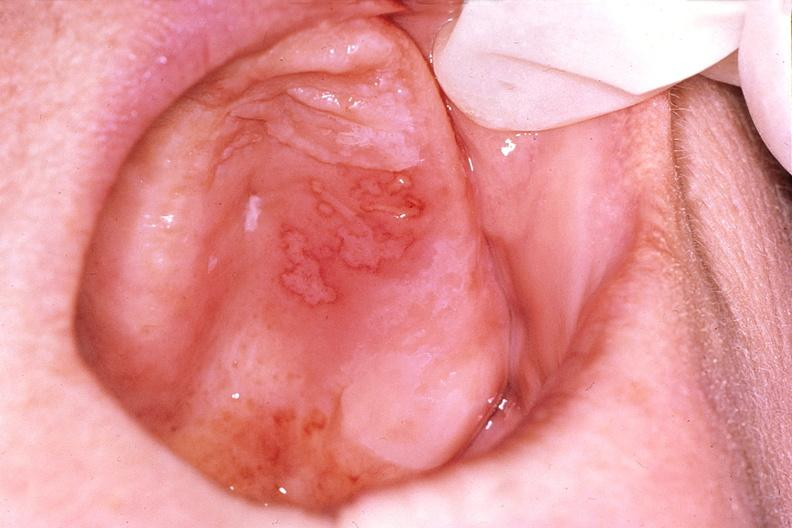does this image show mouth, herpes, ulcers?
Answer the question using a single word or phrase. Yes 